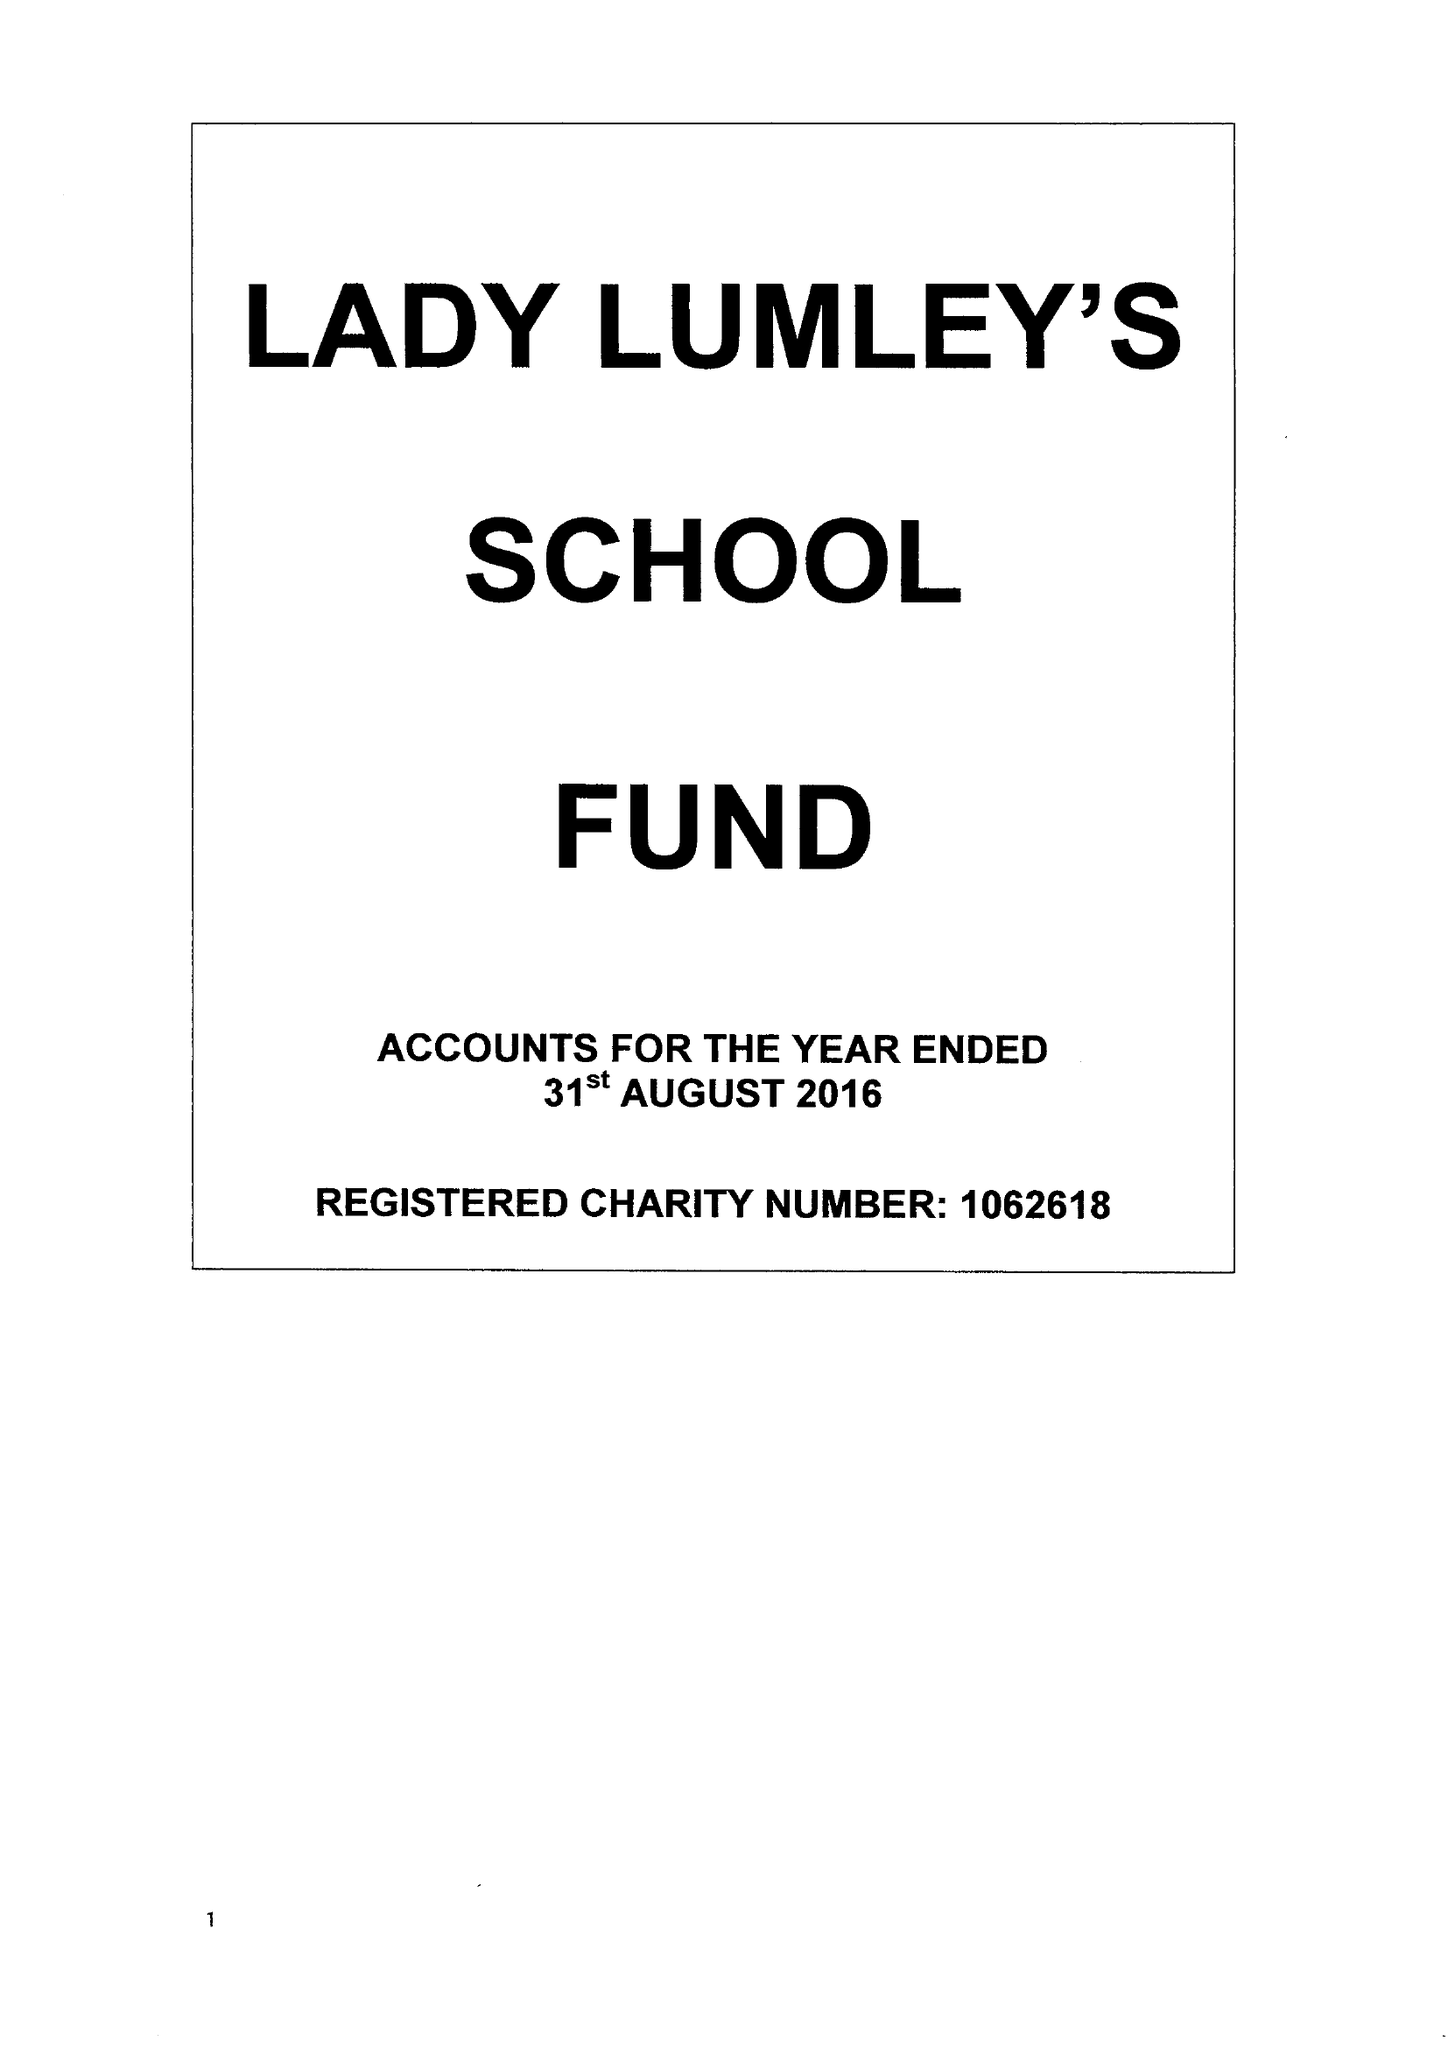What is the value for the charity_number?
Answer the question using a single word or phrase. 1062618 